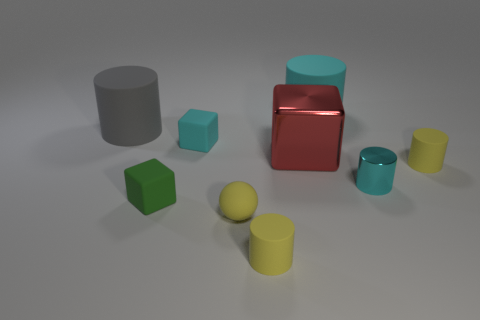How does the lighting in the image affect the appearance of the objects? The lighting in the image is diffuse, providing soft shadows and gentle illumination that reveals the shapes and contours of the objects without creating harsh reflections. This type of lighting allows for the colors and textures of the materials to be seen clearly, emphasizing the volumetric qualities of the objects. 